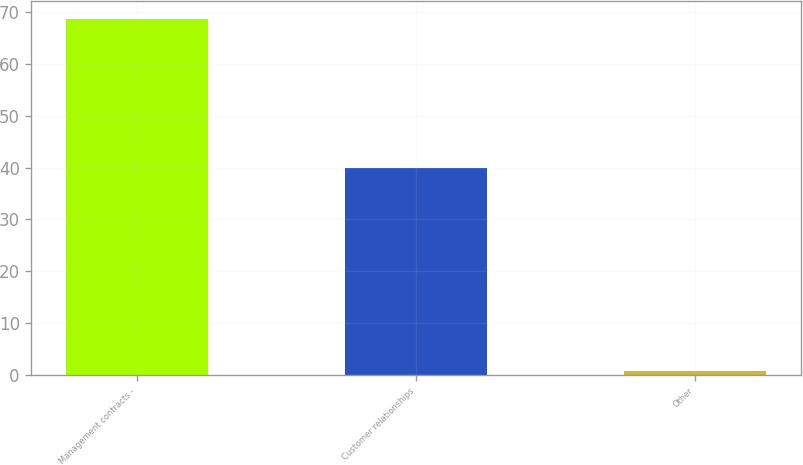Convert chart. <chart><loc_0><loc_0><loc_500><loc_500><bar_chart><fcel>Management contracts -<fcel>Customer relationships<fcel>Other<nl><fcel>68.7<fcel>40<fcel>0.8<nl></chart> 